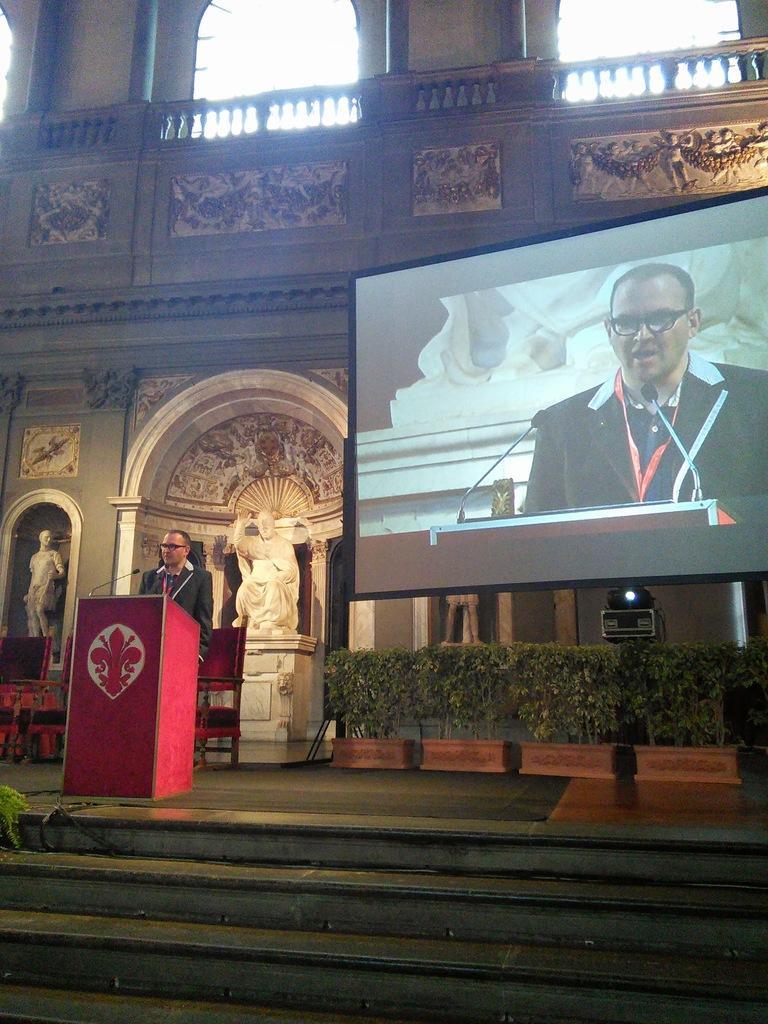Could you give a brief overview of what you see in this image? In the picture we can see a part of the building with some architect and sculpture near it and in front of the building we can see a man standing near the desk, which is red in color and talking into the microphone which is to the desk and beside it we can see the screen with a reflection of a man in it. 